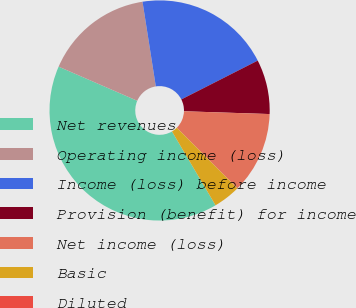Convert chart. <chart><loc_0><loc_0><loc_500><loc_500><pie_chart><fcel>Net revenues<fcel>Operating income (loss)<fcel>Income (loss) before income<fcel>Provision (benefit) for income<fcel>Net income (loss)<fcel>Basic<fcel>Diluted<nl><fcel>40.0%<fcel>16.0%<fcel>20.0%<fcel>8.0%<fcel>12.0%<fcel>4.0%<fcel>0.0%<nl></chart> 